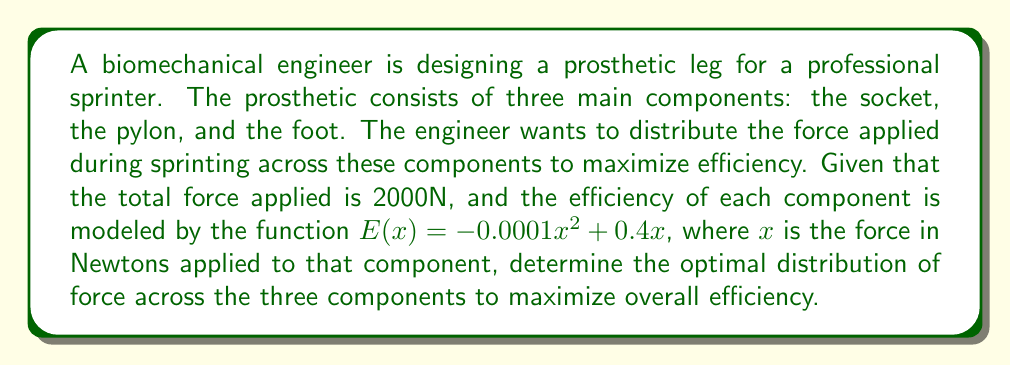Help me with this question. 1) Let $x$, $y$, and $z$ represent the force applied to the socket, pylon, and foot respectively.

2) We need to maximize the total efficiency:
   $E_{total} = E(x) + E(y) + E(z)$
   $= (-0.0001x^2 + 0.4x) + (-0.0001y^2 + 0.4y) + (-0.0001z^2 + 0.4z)$

3) Subject to the constraint: $x + y + z = 2000$

4) This is an optimization problem with a constraint. We can use the method of Lagrange multipliers.

5) Let $L(x,y,z,\lambda) = (-0.0001x^2 + 0.4x) + (-0.0001y^2 + 0.4y) + (-0.0001z^2 + 0.4z) + \lambda(2000 - x - y - z)$

6) Take partial derivatives and set them to zero:

   $\frac{\partial L}{\partial x} = -0.0002x + 0.4 - \lambda = 0$
   $\frac{\partial L}{\partial y} = -0.0002y + 0.4 - \lambda = 0$
   $\frac{\partial L}{\partial z} = -0.0002z + 0.4 - \lambda = 0$
   $\frac{\partial L}{\partial \lambda} = 2000 - x - y - z = 0$

7) From the first three equations, we can see that $x = y = z$

8) Substituting this into the fourth equation:
   $2000 - 3x = 0$
   $x = y = z = \frac{2000}{3} \approx 666.67$

9) Therefore, the optimal distribution is to apply equal force to each component.
Answer: $x = y = z = \frac{2000}{3} \approx 666.67$ N 